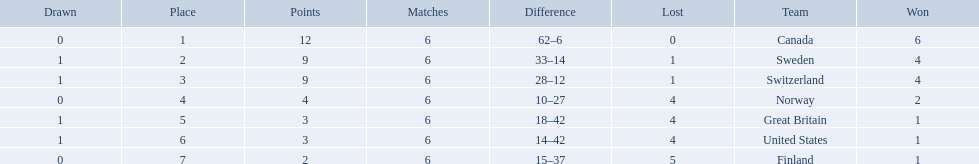What are the names of the countries? Canada, Sweden, Switzerland, Norway, Great Britain, United States, Finland. How many wins did switzerland have? 4. How many wins did great britain have? 1. Which country had more wins, great britain or switzerland? Switzerland. 